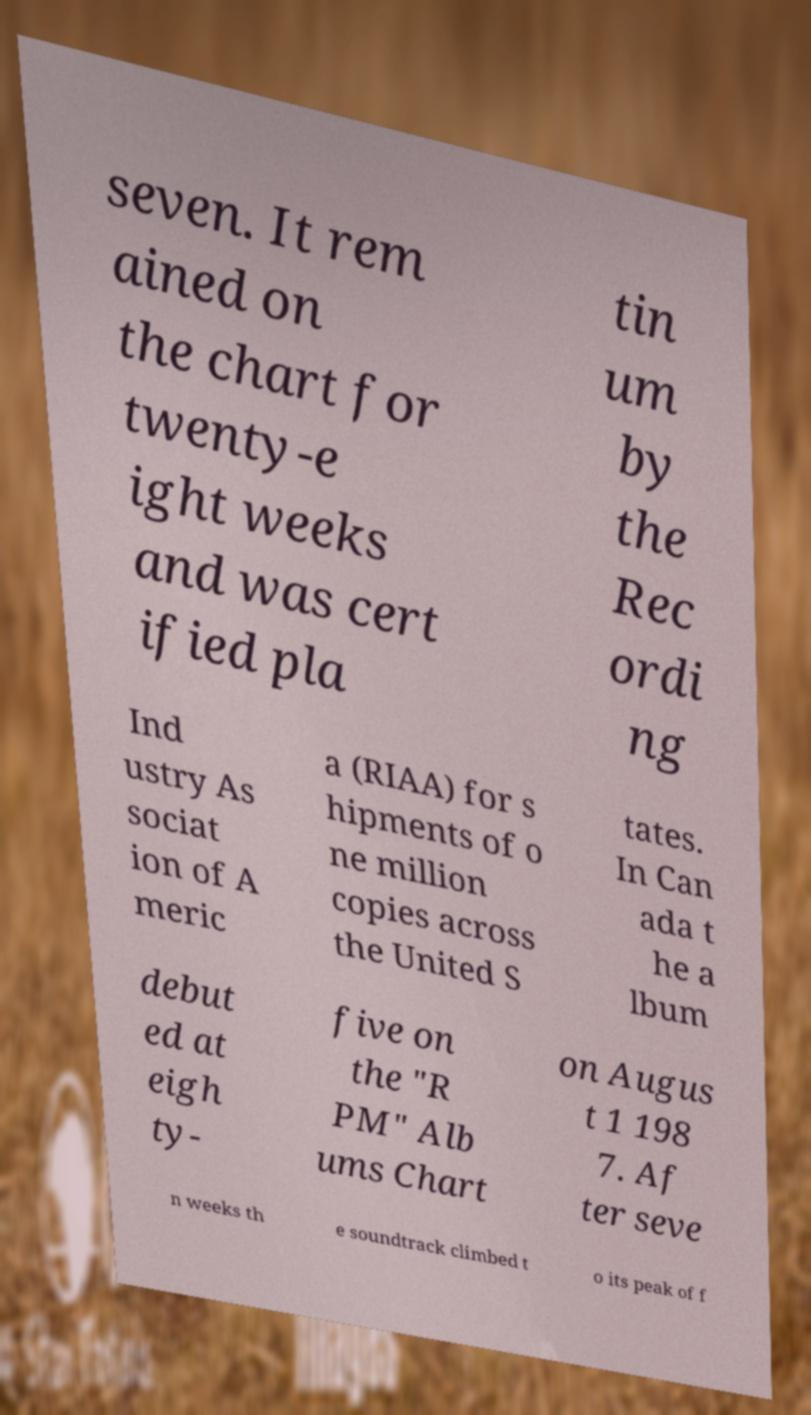Please read and relay the text visible in this image. What does it say? seven. It rem ained on the chart for twenty-e ight weeks and was cert ified pla tin um by the Rec ordi ng Ind ustry As sociat ion of A meric a (RIAA) for s hipments of o ne million copies across the United S tates. In Can ada t he a lbum debut ed at eigh ty- five on the "R PM" Alb ums Chart on Augus t 1 198 7. Af ter seve n weeks th e soundtrack climbed t o its peak of f 